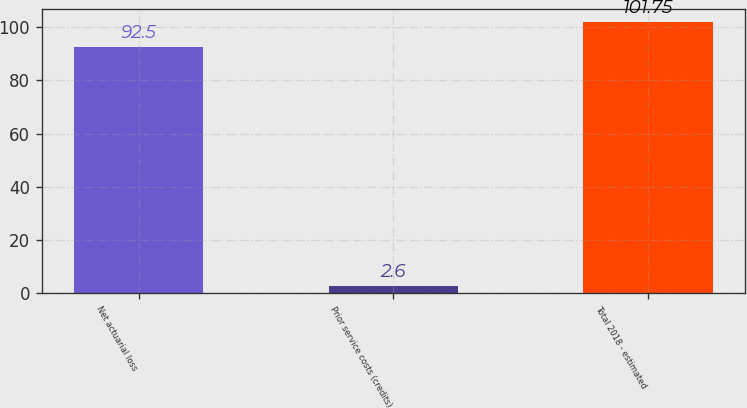Convert chart to OTSL. <chart><loc_0><loc_0><loc_500><loc_500><bar_chart><fcel>Net actuarial loss<fcel>Prior service costs (credits)<fcel>Total 2018 - estimated<nl><fcel>92.5<fcel>2.6<fcel>101.75<nl></chart> 